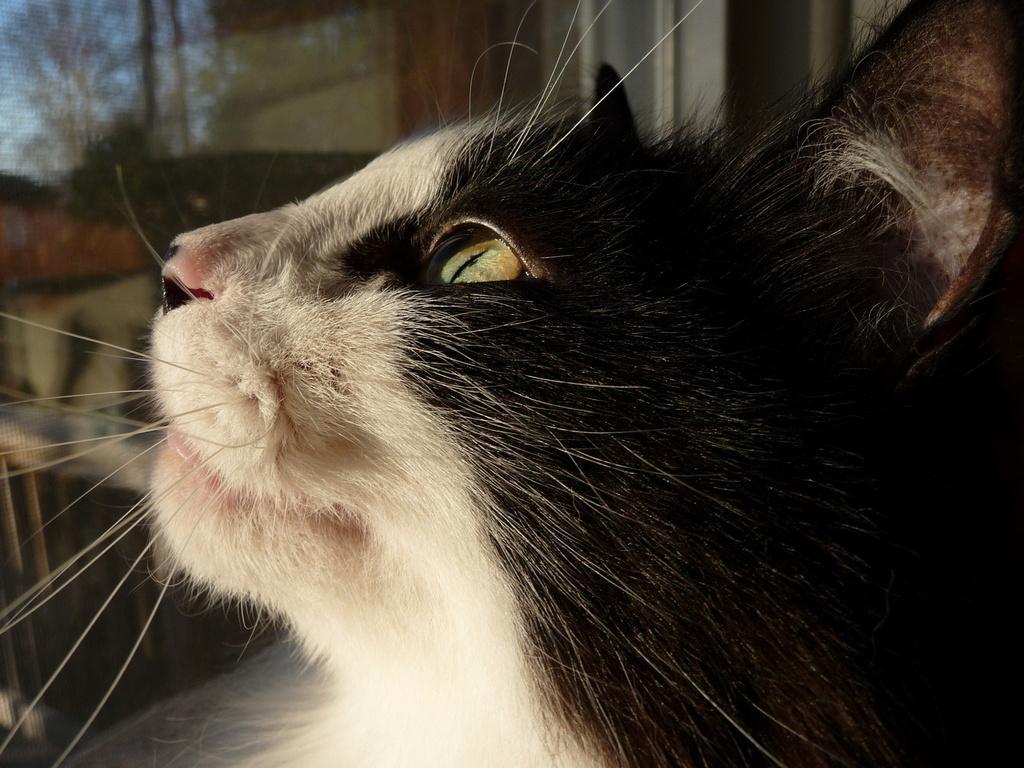Could you give a brief overview of what you see in this image? In this image we can see a cat. In the background there are trees and sky. 